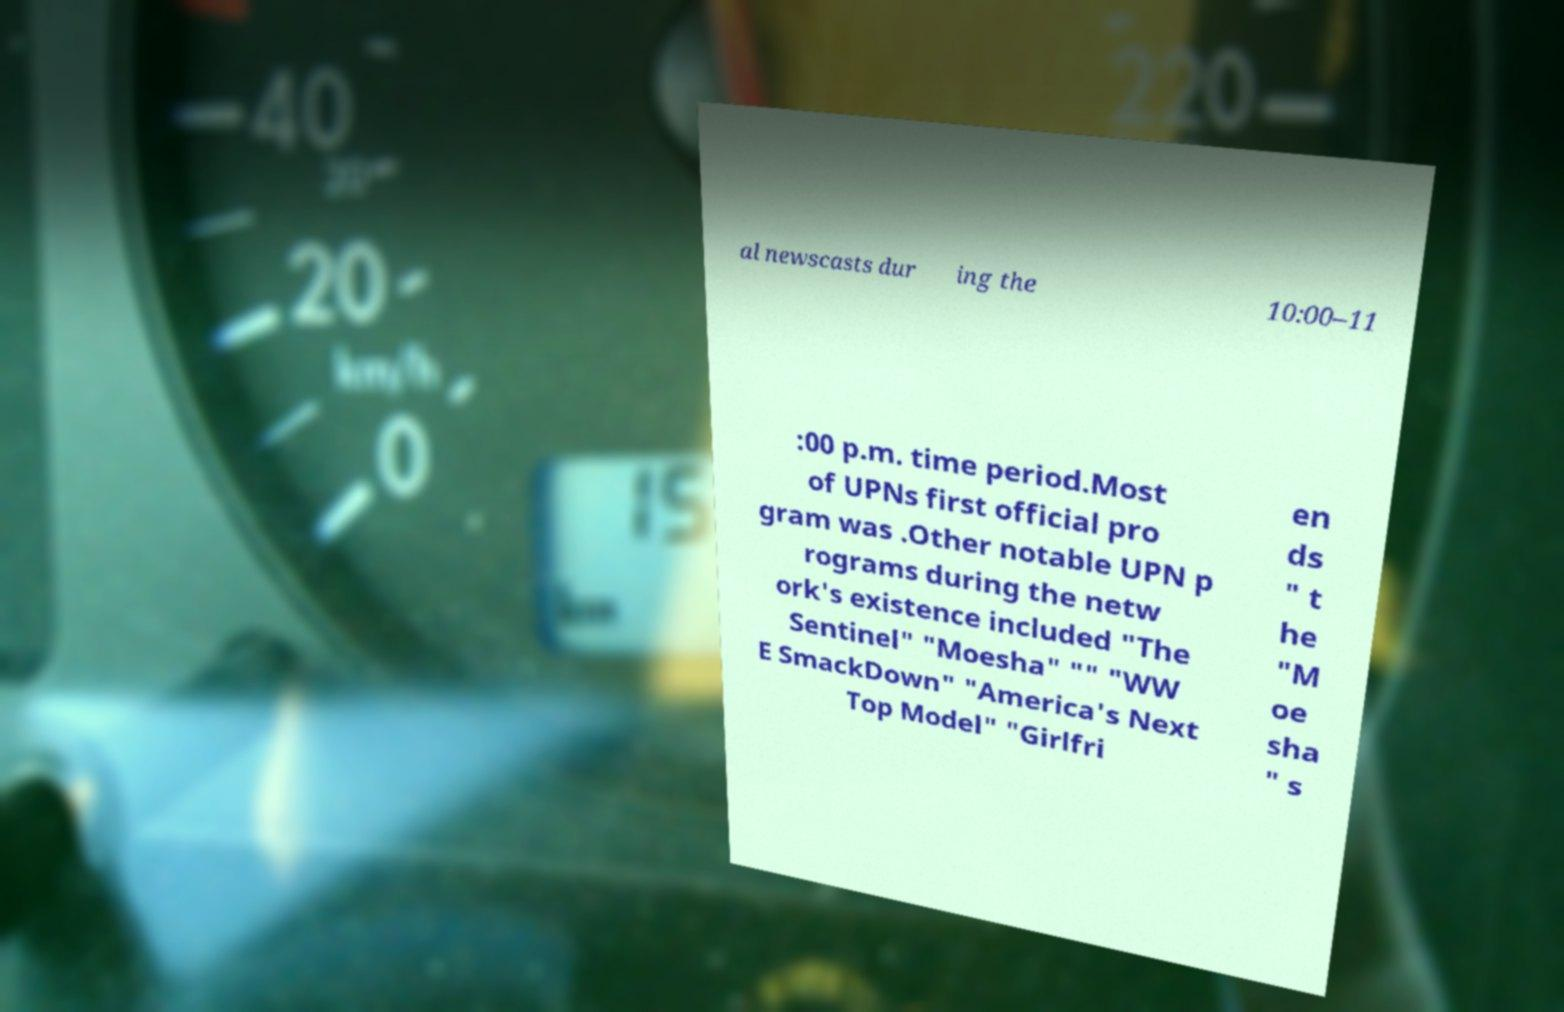Could you extract and type out the text from this image? al newscasts dur ing the 10:00–11 :00 p.m. time period.Most of UPNs first official pro gram was .Other notable UPN p rograms during the netw ork's existence included "The Sentinel" "Moesha" "" "WW E SmackDown" "America's Next Top Model" "Girlfri en ds " t he "M oe sha " s 